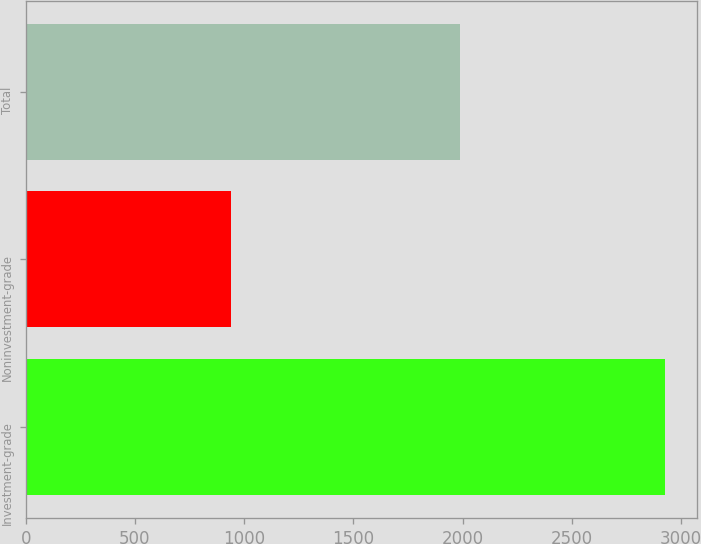Convert chart to OTSL. <chart><loc_0><loc_0><loc_500><loc_500><bar_chart><fcel>Investment-grade<fcel>Noninvestment-grade<fcel>Total<nl><fcel>2929<fcel>941<fcel>1988<nl></chart> 